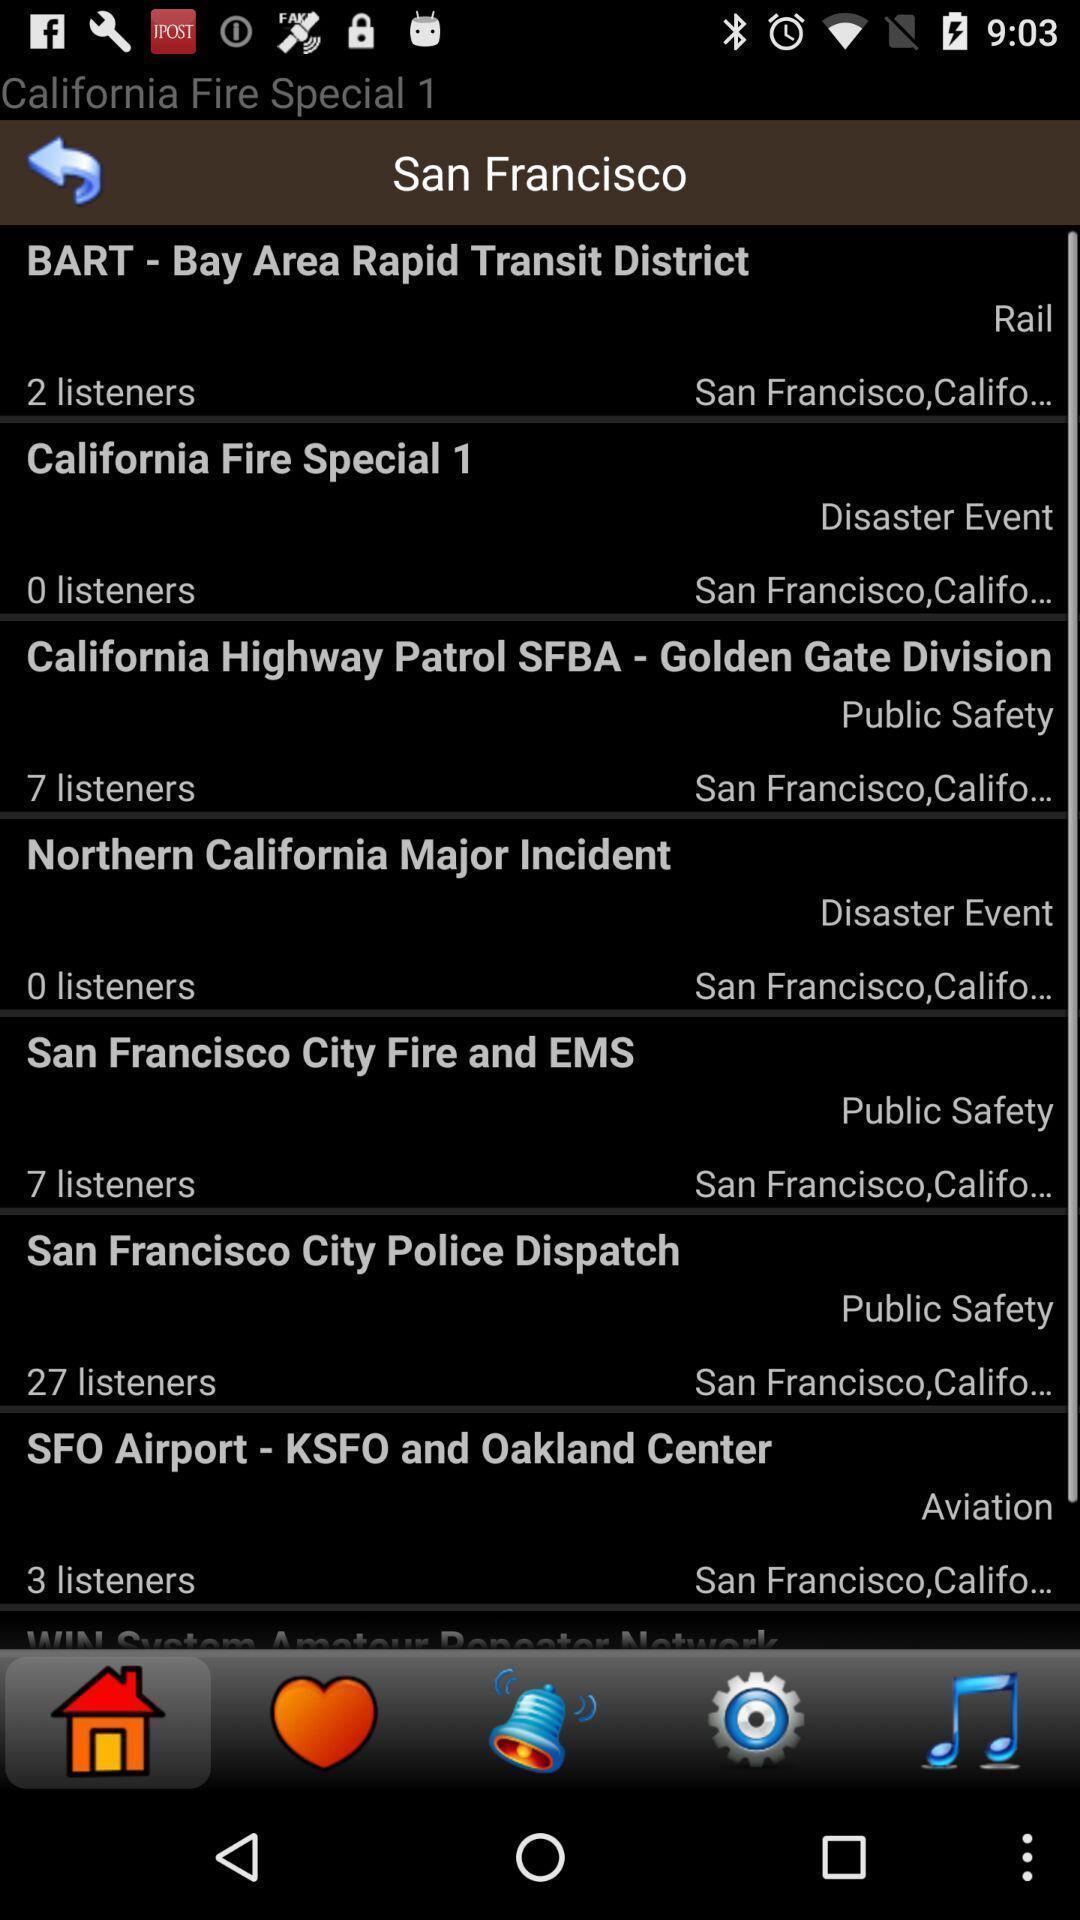Describe the key features of this screenshot. Page showing a list of articles. 